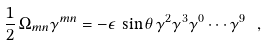Convert formula to latex. <formula><loc_0><loc_0><loc_500><loc_500>\frac { 1 } { 2 } \, \Omega _ { m n } \gamma ^ { m n } = - \epsilon \, \sin \theta \, \gamma ^ { 2 } \gamma ^ { 3 } \gamma ^ { 0 } \cdots \gamma ^ { 9 } \ ,</formula> 